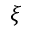Convert formula to latex. <formula><loc_0><loc_0><loc_500><loc_500>\xi</formula> 